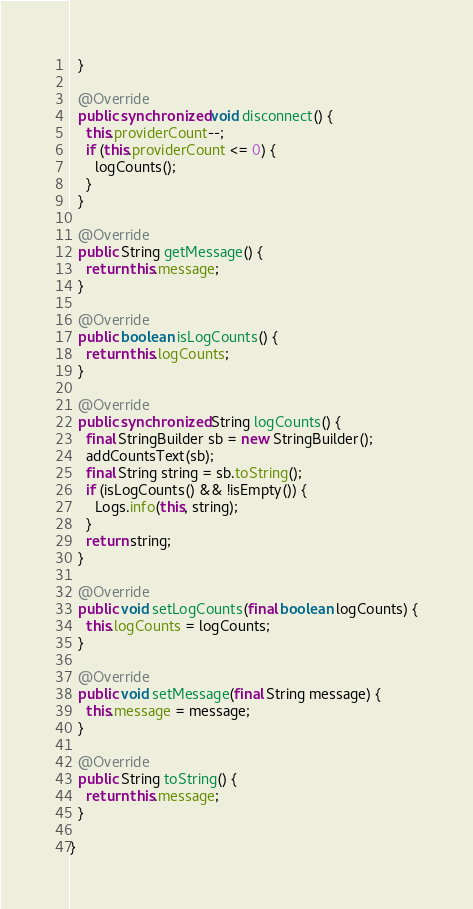<code> <loc_0><loc_0><loc_500><loc_500><_Java_>  }

  @Override
  public synchronized void disconnect() {
    this.providerCount--;
    if (this.providerCount <= 0) {
      logCounts();
    }
  }

  @Override
  public String getMessage() {
    return this.message;
  }

  @Override
  public boolean isLogCounts() {
    return this.logCounts;
  }

  @Override
  public synchronized String logCounts() {
    final StringBuilder sb = new StringBuilder();
    addCountsText(sb);
    final String string = sb.toString();
    if (isLogCounts() && !isEmpty()) {
      Logs.info(this, string);
    }
    return string;
  }

  @Override
  public void setLogCounts(final boolean logCounts) {
    this.logCounts = logCounts;
  }

  @Override
  public void setMessage(final String message) {
    this.message = message;
  }

  @Override
  public String toString() {
    return this.message;
  }

}
</code> 